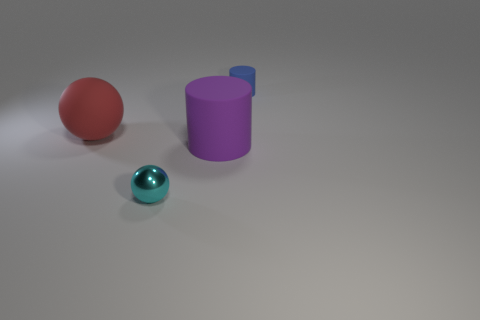Can the lighting in the scene suggest anything about the time of day or location? The lighting in the scene has a soft, diffused quality, lacking any hard shadows or indications of a direct light source such as the sun. This suggests the objects might be located indoors under artificial lighting, rather than outdoors at a particular time of day. It appears to be a controlled environment where the light is used to highlight the objects without revealing much about their broader context. 